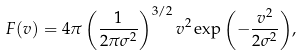<formula> <loc_0><loc_0><loc_500><loc_500>F ( v ) = 4 \pi \left ( \frac { 1 } { 2 \pi \sigma ^ { 2 } } \right ) ^ { 3 / 2 } v ^ { 2 } \exp { \left ( - \frac { v ^ { 2 } } { 2 \sigma ^ { 2 } } \right ) } ,</formula> 